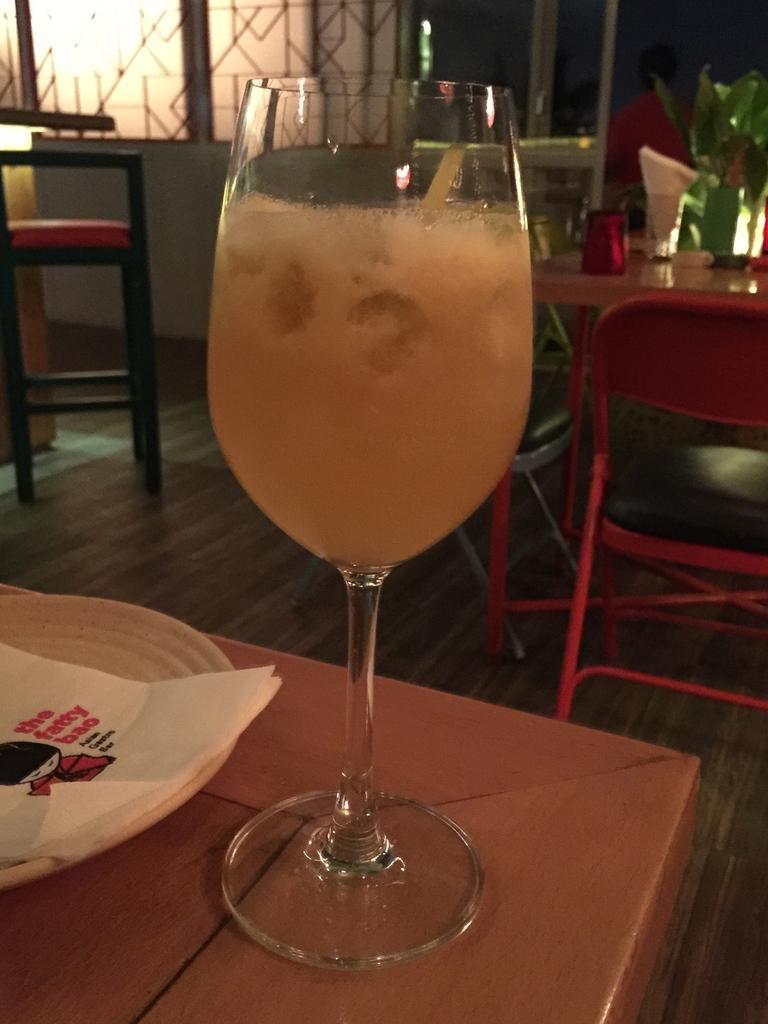Please provide a concise description of this image. In this image I see a glass and a plate on which there is a tissue, which are on the table. In the background I see chairs and table over here on which there are few things. 